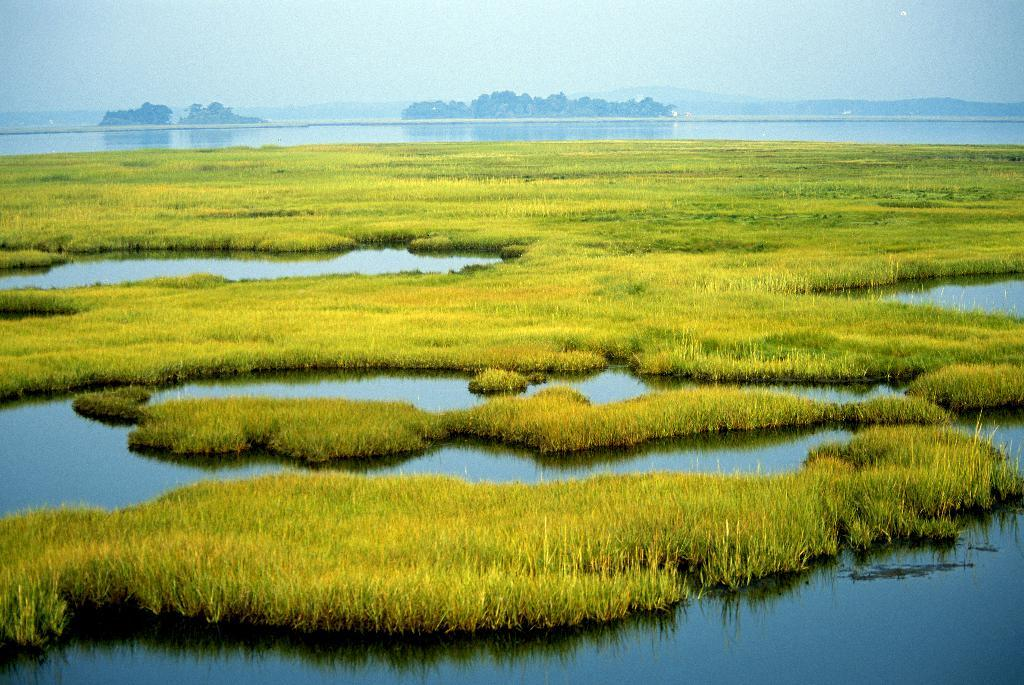What type of vegetation is present in the image? There is grass in the image. What natural element is visible in the image besides grass? There is water visible in the image. What can be seen in the background of the image? There are trees and hills in the background of the image. What part of the natural environment is visible in the background of the image? The sky is visible in the background of the image. What flavor of ice cream is being served in the bucket in the image? There is no bucket or ice cream present in the image. 